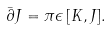<formula> <loc_0><loc_0><loc_500><loc_500>\bar { \partial } J = \pi \epsilon \, [ K , J ] .</formula> 